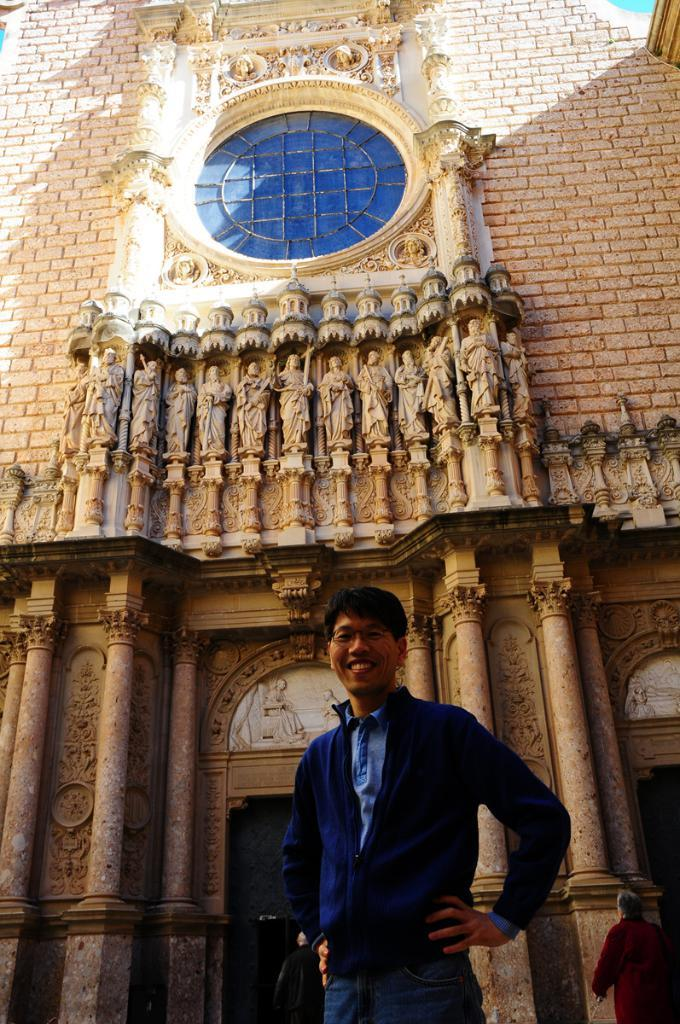Who is present in the image? There is a man in the image. What is the man wearing? The man is wearing a blue shirt. What can be seen in the background of the image? There is a building in the background of the image. What type of horse can be seen in the image? There is no horse present in the image. What nerve is the man stimulating in the image? The image does not show the man stimulating any nerve. 